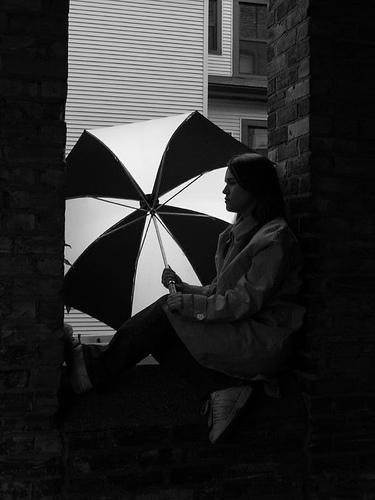Is the girl lonely?
Be succinct. Yes. What colors are the umbrella?
Quick response, please. Black and white. Are the girl's shoes tied?
Keep it brief. Yes. What is the girl holding?
Short answer required. Umbrella. Is the umbrella broken?
Short answer required. No. 